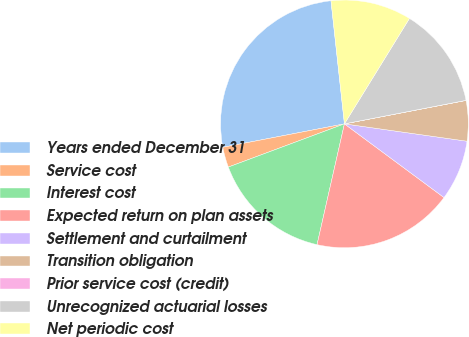Convert chart. <chart><loc_0><loc_0><loc_500><loc_500><pie_chart><fcel>Years ended December 31<fcel>Service cost<fcel>Interest cost<fcel>Expected return on plan assets<fcel>Settlement and curtailment<fcel>Transition obligation<fcel>Prior service cost (credit)<fcel>Unrecognized actuarial losses<fcel>Net periodic cost<nl><fcel>26.3%<fcel>2.64%<fcel>15.78%<fcel>18.41%<fcel>7.9%<fcel>5.27%<fcel>0.01%<fcel>13.16%<fcel>10.53%<nl></chart> 